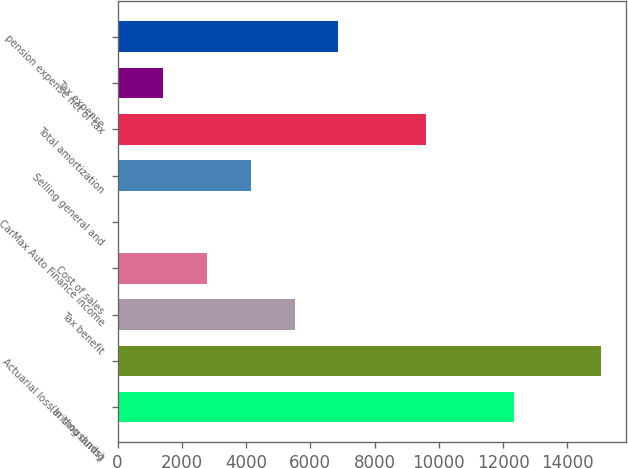Convert chart. <chart><loc_0><loc_0><loc_500><loc_500><bar_chart><fcel>(In thousands)<fcel>Actuarial loss arising during<fcel>Tax benefit<fcel>Cost of sales<fcel>CarMax Auto Finance income<fcel>Selling general and<fcel>Total amortization<fcel>Tax expense<fcel>pension expense net of tax<nl><fcel>12333.3<fcel>15062.7<fcel>5509.8<fcel>2780.4<fcel>51<fcel>4145.1<fcel>9603.9<fcel>1415.7<fcel>6874.5<nl></chart> 